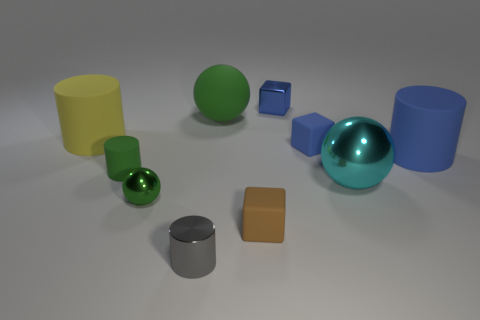The other ball that is the same color as the tiny metal sphere is what size?
Offer a very short reply. Large. What size is the ball that is in front of the large blue cylinder and to the right of the small metal ball?
Keep it short and to the point. Large. How many green shiny things are on the left side of the big thing behind the large matte cylinder to the left of the cyan metallic ball?
Make the answer very short. 1. Are there any matte cylinders that have the same color as the metal cube?
Your answer should be very brief. Yes. There is a rubber cylinder that is the same size as the brown rubber cube; what is its color?
Offer a very short reply. Green. There is a tiny blue object that is behind the rubber thing that is behind the thing that is on the left side of the green cylinder; what is its shape?
Your answer should be compact. Cube. There is a big rubber cylinder that is on the left side of the tiny metallic sphere; how many tiny spheres are behind it?
Ensure brevity in your answer.  0. Is the shape of the object in front of the small brown rubber block the same as the big object that is left of the green metal sphere?
Your response must be concise. Yes. There is a gray shiny cylinder; how many cylinders are on the left side of it?
Make the answer very short. 2. Do the small cylinder in front of the green cylinder and the large cyan sphere have the same material?
Your response must be concise. Yes. 